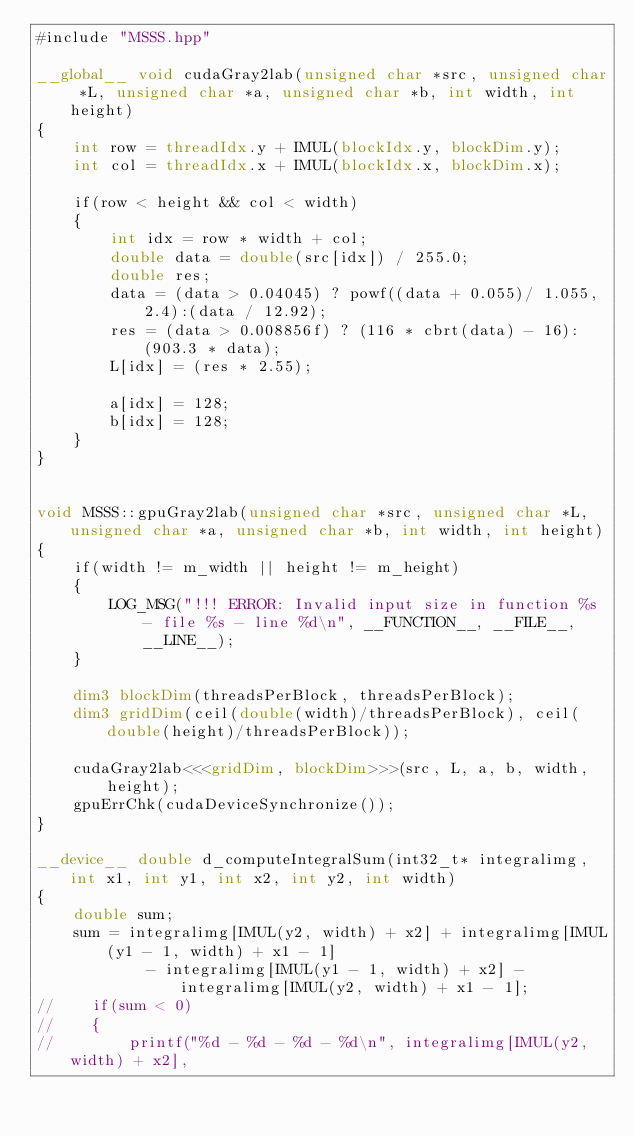Convert code to text. <code><loc_0><loc_0><loc_500><loc_500><_Cuda_>#include "MSSS.hpp"

__global__ void cudaGray2lab(unsigned char *src, unsigned char *L, unsigned char *a, unsigned char *b, int width, int height)
{
    int row = threadIdx.y + IMUL(blockIdx.y, blockDim.y);
    int col = threadIdx.x + IMUL(blockIdx.x, blockDim.x);

    if(row < height && col < width)
    {
        int idx = row * width + col;
        double data = double(src[idx]) / 255.0;
        double res;
        data = (data > 0.04045) ? powf((data + 0.055)/ 1.055, 2.4):(data / 12.92);
        res = (data > 0.008856f) ? (116 * cbrt(data) - 16): (903.3 * data);
        L[idx] = (res * 2.55);

        a[idx] = 128;
        b[idx] = 128;
    }
}


void MSSS::gpuGray2lab(unsigned char *src, unsigned char *L, unsigned char *a, unsigned char *b, int width, int height)
{
    if(width != m_width || height != m_height)
    {
        LOG_MSG("!!! ERROR: Invalid input size in function %s - file %s - line %d\n", __FUNCTION__, __FILE__, __LINE__);
    }

    dim3 blockDim(threadsPerBlock, threadsPerBlock);
    dim3 gridDim(ceil(double(width)/threadsPerBlock), ceil(double(height)/threadsPerBlock));

    cudaGray2lab<<<gridDim, blockDim>>>(src, L, a, b, width, height);
    gpuErrChk(cudaDeviceSynchronize());
}

__device__ double d_computeIntegralSum(int32_t* integralimg, int x1, int y1, int x2, int y2, int width)
{
    double sum;
    sum = integralimg[IMUL(y2, width) + x2] + integralimg[IMUL(y1 - 1, width) + x1 - 1]
            - integralimg[IMUL(y1 - 1, width) + x2] - integralimg[IMUL(y2, width) + x1 - 1];
//    if(sum < 0)
//    {
//        printf("%d - %d - %d - %d\n", integralimg[IMUL(y2, width) + x2],</code> 